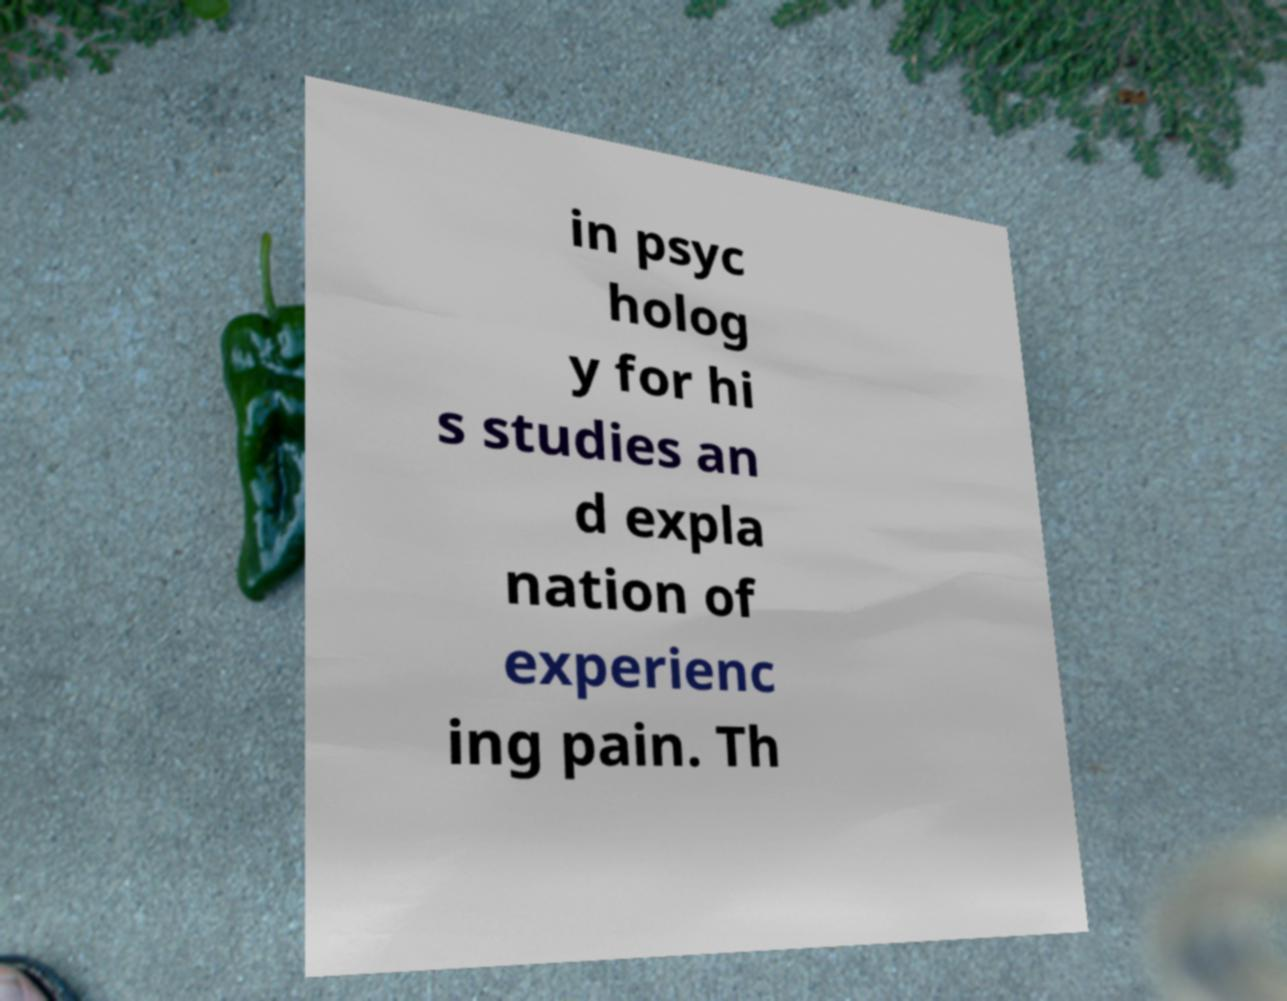Can you accurately transcribe the text from the provided image for me? in psyc holog y for hi s studies an d expla nation of experienc ing pain. Th 